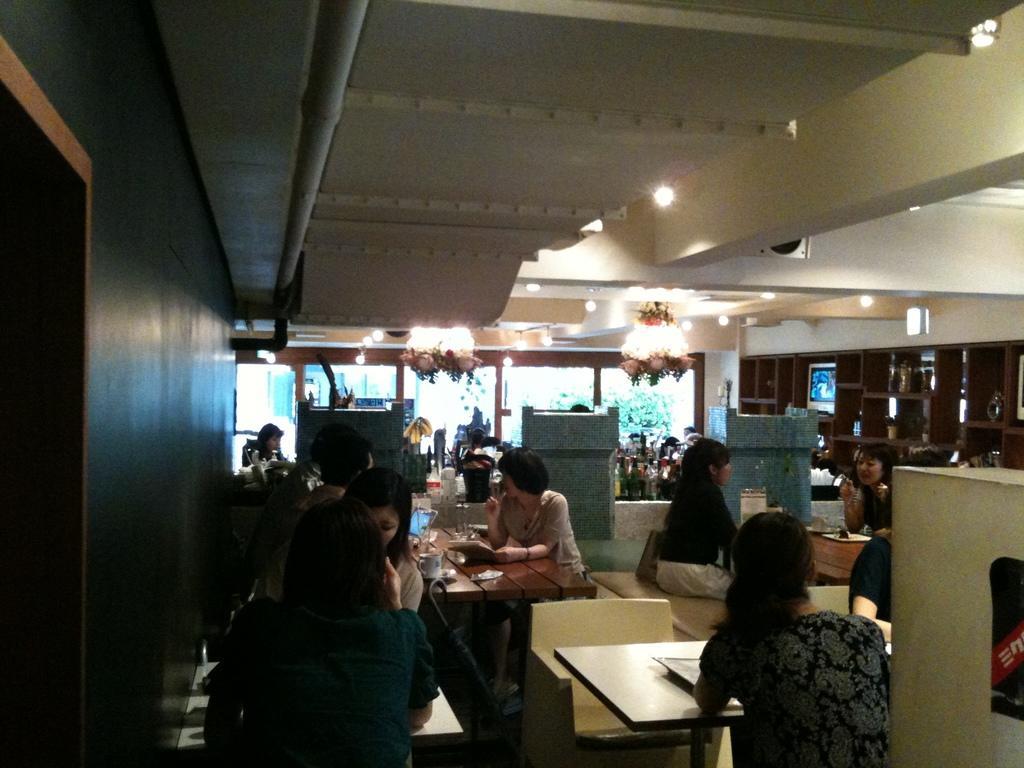Could you give a brief overview of what you see in this image? In a room there are many people sitting on the chairs. In front of them there are tables with menu cards, cups, plate, books and glasses on it. Behind them there are 3 podiums. On the top there are lightnings. And to the right side there is a cupboard. And there are some window with glasses. 